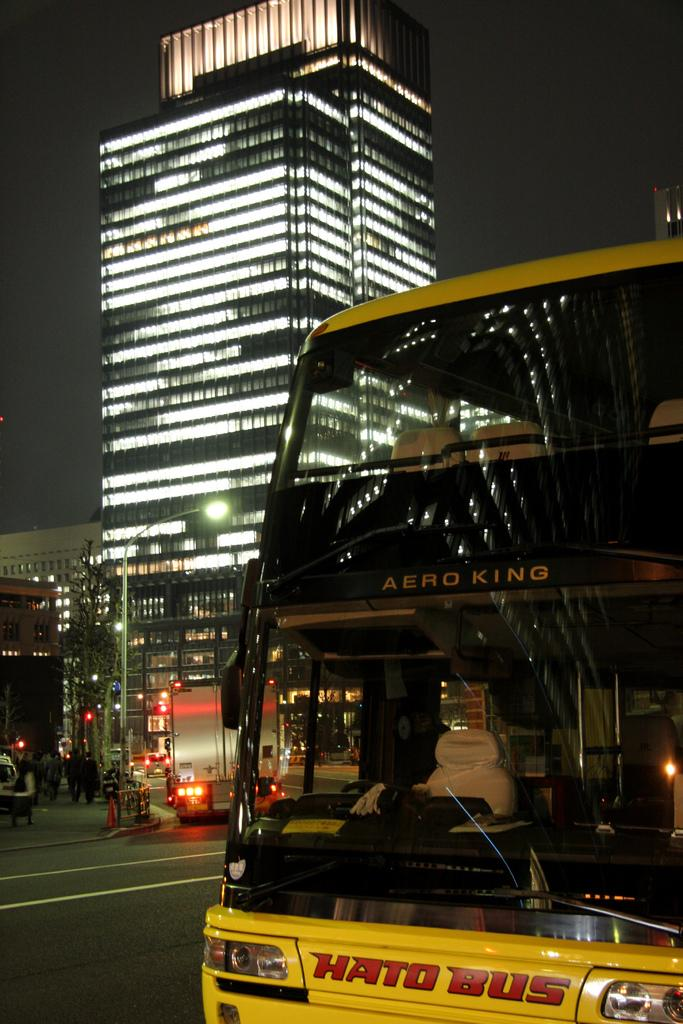<image>
Offer a succinct explanation of the picture presented. A yellow Hato bus drives past a lighted building on the corner. 